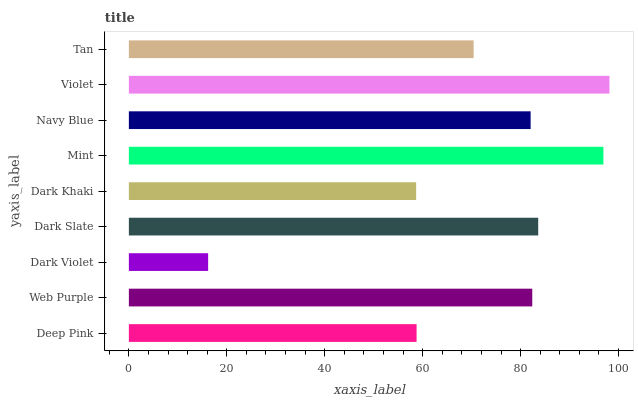Is Dark Violet the minimum?
Answer yes or no. Yes. Is Violet the maximum?
Answer yes or no. Yes. Is Web Purple the minimum?
Answer yes or no. No. Is Web Purple the maximum?
Answer yes or no. No. Is Web Purple greater than Deep Pink?
Answer yes or no. Yes. Is Deep Pink less than Web Purple?
Answer yes or no. Yes. Is Deep Pink greater than Web Purple?
Answer yes or no. No. Is Web Purple less than Deep Pink?
Answer yes or no. No. Is Navy Blue the high median?
Answer yes or no. Yes. Is Navy Blue the low median?
Answer yes or no. Yes. Is Tan the high median?
Answer yes or no. No. Is Deep Pink the low median?
Answer yes or no. No. 